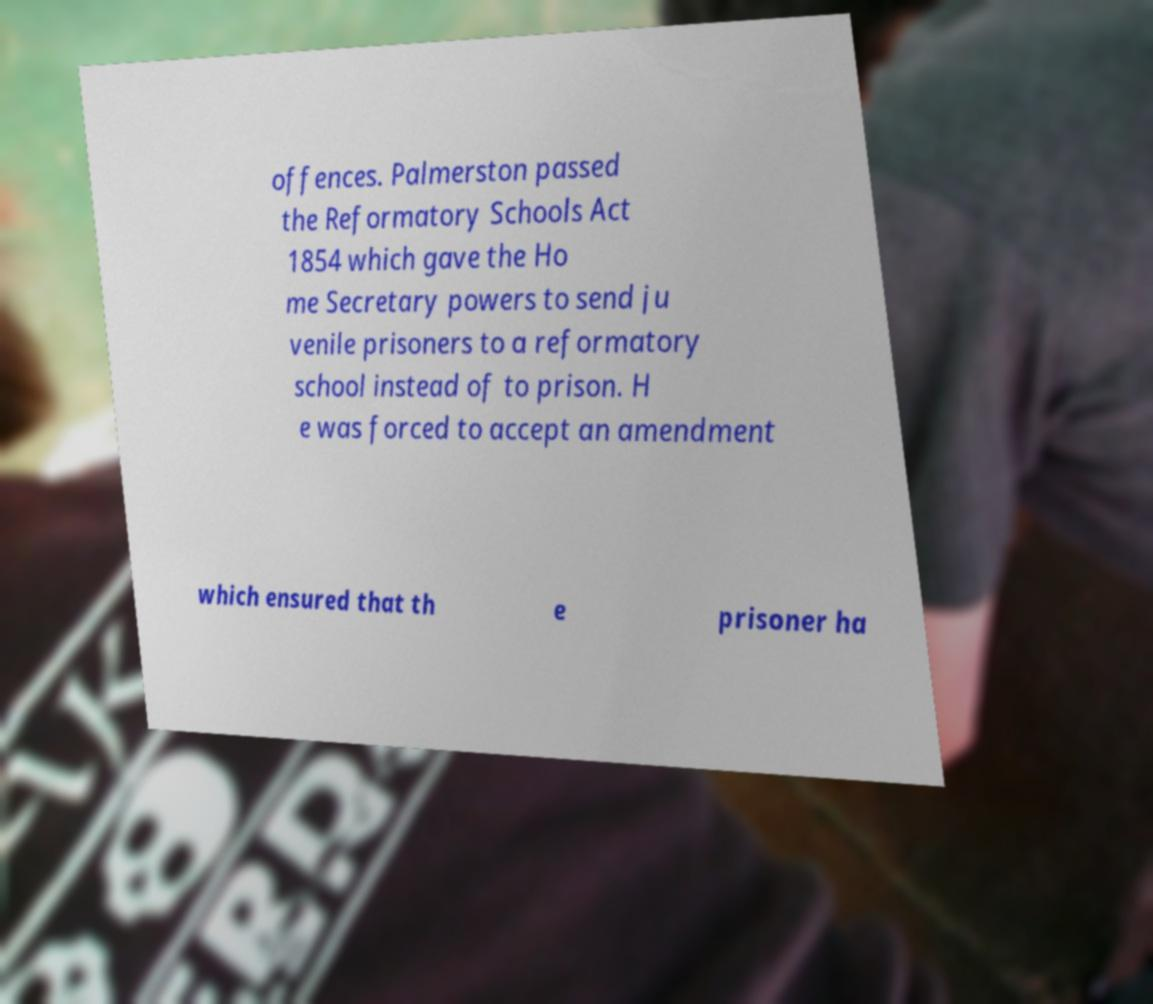Can you accurately transcribe the text from the provided image for me? offences. Palmerston passed the Reformatory Schools Act 1854 which gave the Ho me Secretary powers to send ju venile prisoners to a reformatory school instead of to prison. H e was forced to accept an amendment which ensured that th e prisoner ha 